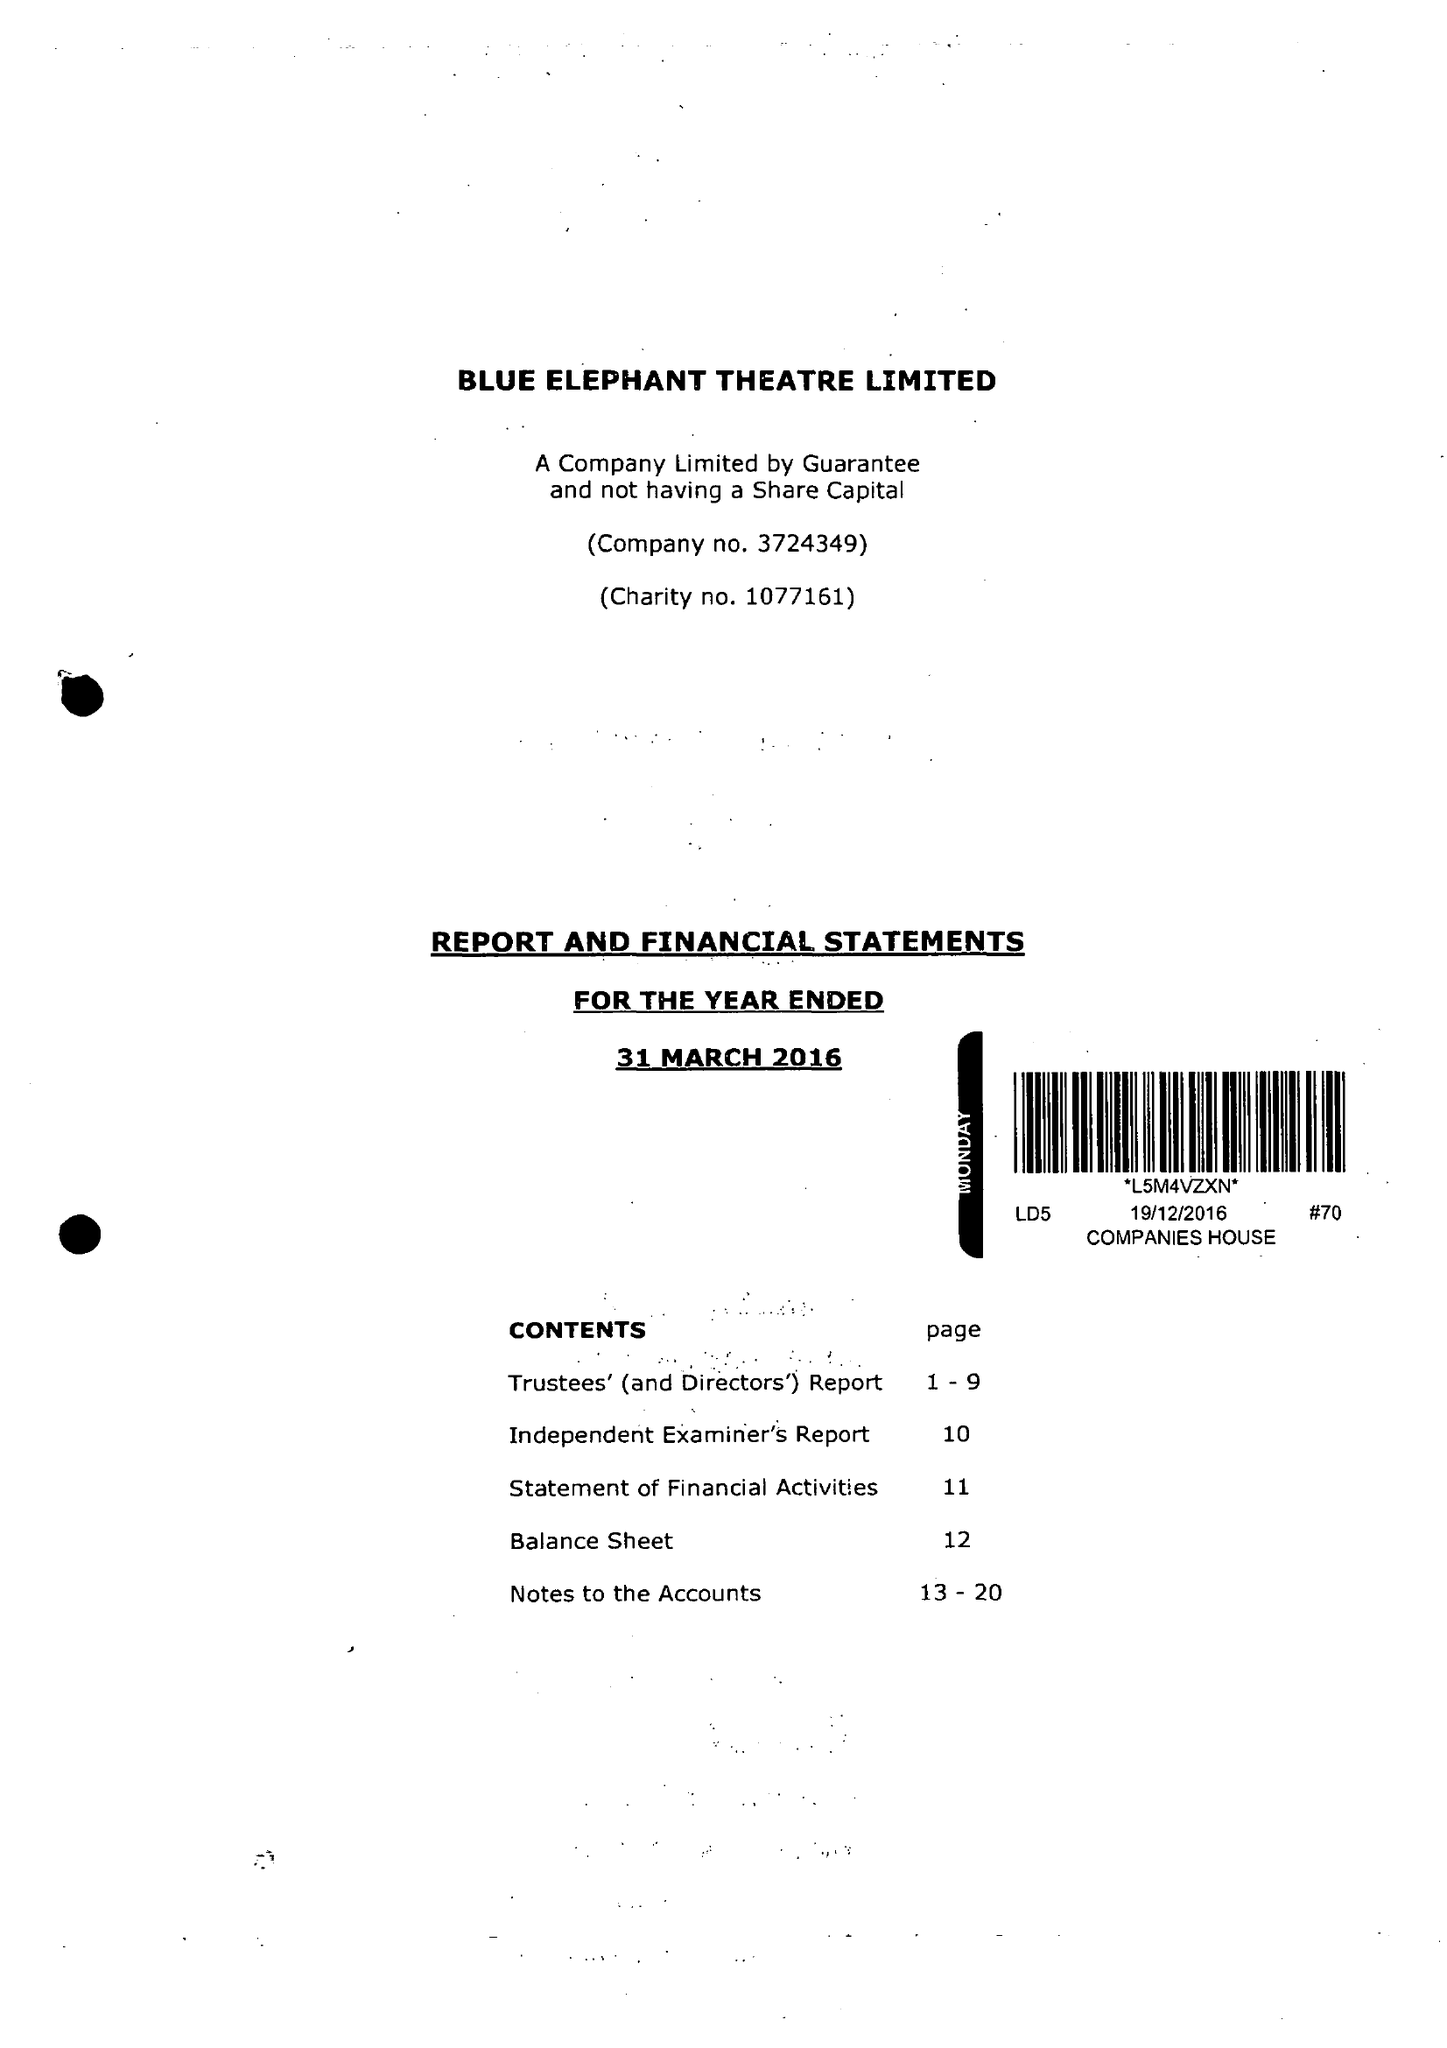What is the value for the income_annually_in_british_pounds?
Answer the question using a single word or phrase. 166202.00 